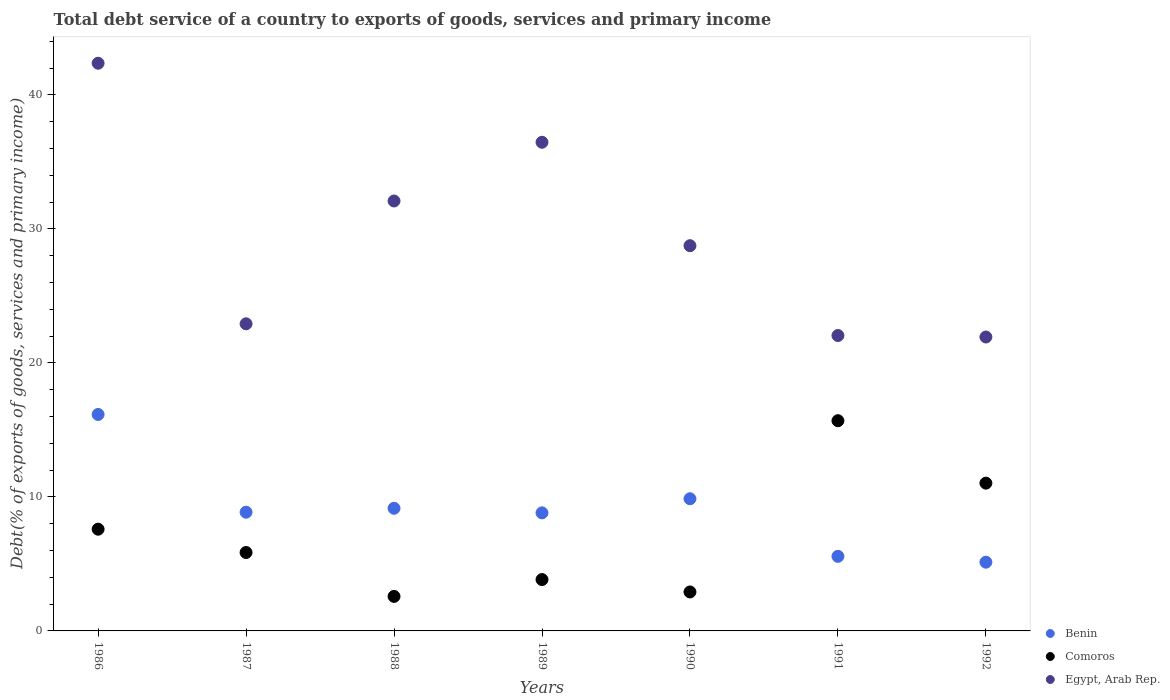Is the number of dotlines equal to the number of legend labels?
Ensure brevity in your answer.  Yes. What is the total debt service in Comoros in 1990?
Make the answer very short. 2.91. Across all years, what is the maximum total debt service in Comoros?
Your answer should be compact. 15.69. Across all years, what is the minimum total debt service in Comoros?
Ensure brevity in your answer.  2.58. In which year was the total debt service in Benin minimum?
Your answer should be compact. 1992. What is the total total debt service in Egypt, Arab Rep. in the graph?
Give a very brief answer. 206.56. What is the difference between the total debt service in Egypt, Arab Rep. in 1986 and that in 1987?
Provide a short and direct response. 19.45. What is the difference between the total debt service in Benin in 1988 and the total debt service in Egypt, Arab Rep. in 1990?
Your response must be concise. -19.6. What is the average total debt service in Comoros per year?
Ensure brevity in your answer.  7.07. In the year 1992, what is the difference between the total debt service in Benin and total debt service in Comoros?
Keep it short and to the point. -5.9. In how many years, is the total debt service in Egypt, Arab Rep. greater than 8 %?
Offer a terse response. 7. What is the ratio of the total debt service in Comoros in 1986 to that in 1992?
Your answer should be compact. 0.69. Is the difference between the total debt service in Benin in 1990 and 1991 greater than the difference between the total debt service in Comoros in 1990 and 1991?
Provide a succinct answer. Yes. What is the difference between the highest and the second highest total debt service in Egypt, Arab Rep.?
Your answer should be compact. 5.9. What is the difference between the highest and the lowest total debt service in Egypt, Arab Rep.?
Your answer should be compact. 20.43. In how many years, is the total debt service in Benin greater than the average total debt service in Benin taken over all years?
Your response must be concise. 3. Is the sum of the total debt service in Egypt, Arab Rep. in 1987 and 1991 greater than the maximum total debt service in Benin across all years?
Ensure brevity in your answer.  Yes. Is it the case that in every year, the sum of the total debt service in Egypt, Arab Rep. and total debt service in Comoros  is greater than the total debt service in Benin?
Your response must be concise. Yes. How many dotlines are there?
Offer a terse response. 3. How many years are there in the graph?
Provide a short and direct response. 7. Does the graph contain any zero values?
Ensure brevity in your answer.  No. Does the graph contain grids?
Provide a succinct answer. No. Where does the legend appear in the graph?
Offer a very short reply. Bottom right. How many legend labels are there?
Offer a terse response. 3. How are the legend labels stacked?
Keep it short and to the point. Vertical. What is the title of the graph?
Provide a short and direct response. Total debt service of a country to exports of goods, services and primary income. Does "Samoa" appear as one of the legend labels in the graph?
Make the answer very short. No. What is the label or title of the Y-axis?
Your answer should be compact. Debt(% of exports of goods, services and primary income). What is the Debt(% of exports of goods, services and primary income) in Benin in 1986?
Your answer should be very brief. 16.15. What is the Debt(% of exports of goods, services and primary income) in Comoros in 1986?
Make the answer very short. 7.59. What is the Debt(% of exports of goods, services and primary income) of Egypt, Arab Rep. in 1986?
Ensure brevity in your answer.  42.36. What is the Debt(% of exports of goods, services and primary income) in Benin in 1987?
Ensure brevity in your answer.  8.86. What is the Debt(% of exports of goods, services and primary income) of Comoros in 1987?
Keep it short and to the point. 5.85. What is the Debt(% of exports of goods, services and primary income) in Egypt, Arab Rep. in 1987?
Provide a succinct answer. 22.92. What is the Debt(% of exports of goods, services and primary income) of Benin in 1988?
Your response must be concise. 9.15. What is the Debt(% of exports of goods, services and primary income) in Comoros in 1988?
Offer a very short reply. 2.58. What is the Debt(% of exports of goods, services and primary income) of Egypt, Arab Rep. in 1988?
Give a very brief answer. 32.08. What is the Debt(% of exports of goods, services and primary income) in Benin in 1989?
Provide a succinct answer. 8.81. What is the Debt(% of exports of goods, services and primary income) of Comoros in 1989?
Provide a short and direct response. 3.83. What is the Debt(% of exports of goods, services and primary income) in Egypt, Arab Rep. in 1989?
Your answer should be very brief. 36.47. What is the Debt(% of exports of goods, services and primary income) in Benin in 1990?
Give a very brief answer. 9.86. What is the Debt(% of exports of goods, services and primary income) in Comoros in 1990?
Offer a very short reply. 2.91. What is the Debt(% of exports of goods, services and primary income) in Egypt, Arab Rep. in 1990?
Ensure brevity in your answer.  28.75. What is the Debt(% of exports of goods, services and primary income) in Benin in 1991?
Provide a short and direct response. 5.57. What is the Debt(% of exports of goods, services and primary income) of Comoros in 1991?
Ensure brevity in your answer.  15.69. What is the Debt(% of exports of goods, services and primary income) of Egypt, Arab Rep. in 1991?
Your answer should be compact. 22.04. What is the Debt(% of exports of goods, services and primary income) in Benin in 1992?
Your response must be concise. 5.13. What is the Debt(% of exports of goods, services and primary income) in Comoros in 1992?
Your answer should be compact. 11.03. What is the Debt(% of exports of goods, services and primary income) of Egypt, Arab Rep. in 1992?
Provide a succinct answer. 21.93. Across all years, what is the maximum Debt(% of exports of goods, services and primary income) of Benin?
Ensure brevity in your answer.  16.15. Across all years, what is the maximum Debt(% of exports of goods, services and primary income) in Comoros?
Provide a short and direct response. 15.69. Across all years, what is the maximum Debt(% of exports of goods, services and primary income) of Egypt, Arab Rep.?
Make the answer very short. 42.36. Across all years, what is the minimum Debt(% of exports of goods, services and primary income) of Benin?
Ensure brevity in your answer.  5.13. Across all years, what is the minimum Debt(% of exports of goods, services and primary income) of Comoros?
Your response must be concise. 2.58. Across all years, what is the minimum Debt(% of exports of goods, services and primary income) of Egypt, Arab Rep.?
Offer a very short reply. 21.93. What is the total Debt(% of exports of goods, services and primary income) of Benin in the graph?
Your answer should be very brief. 63.54. What is the total Debt(% of exports of goods, services and primary income) in Comoros in the graph?
Keep it short and to the point. 49.48. What is the total Debt(% of exports of goods, services and primary income) in Egypt, Arab Rep. in the graph?
Ensure brevity in your answer.  206.56. What is the difference between the Debt(% of exports of goods, services and primary income) of Benin in 1986 and that in 1987?
Provide a succinct answer. 7.29. What is the difference between the Debt(% of exports of goods, services and primary income) of Comoros in 1986 and that in 1987?
Offer a very short reply. 1.74. What is the difference between the Debt(% of exports of goods, services and primary income) of Egypt, Arab Rep. in 1986 and that in 1987?
Your answer should be very brief. 19.45. What is the difference between the Debt(% of exports of goods, services and primary income) in Benin in 1986 and that in 1988?
Provide a short and direct response. 7. What is the difference between the Debt(% of exports of goods, services and primary income) of Comoros in 1986 and that in 1988?
Ensure brevity in your answer.  5.01. What is the difference between the Debt(% of exports of goods, services and primary income) of Egypt, Arab Rep. in 1986 and that in 1988?
Make the answer very short. 10.28. What is the difference between the Debt(% of exports of goods, services and primary income) in Benin in 1986 and that in 1989?
Offer a terse response. 7.34. What is the difference between the Debt(% of exports of goods, services and primary income) in Comoros in 1986 and that in 1989?
Your response must be concise. 3.76. What is the difference between the Debt(% of exports of goods, services and primary income) of Egypt, Arab Rep. in 1986 and that in 1989?
Ensure brevity in your answer.  5.9. What is the difference between the Debt(% of exports of goods, services and primary income) of Benin in 1986 and that in 1990?
Provide a short and direct response. 6.29. What is the difference between the Debt(% of exports of goods, services and primary income) of Comoros in 1986 and that in 1990?
Offer a very short reply. 4.68. What is the difference between the Debt(% of exports of goods, services and primary income) in Egypt, Arab Rep. in 1986 and that in 1990?
Ensure brevity in your answer.  13.62. What is the difference between the Debt(% of exports of goods, services and primary income) in Benin in 1986 and that in 1991?
Keep it short and to the point. 10.59. What is the difference between the Debt(% of exports of goods, services and primary income) of Comoros in 1986 and that in 1991?
Make the answer very short. -8.1. What is the difference between the Debt(% of exports of goods, services and primary income) of Egypt, Arab Rep. in 1986 and that in 1991?
Your response must be concise. 20.32. What is the difference between the Debt(% of exports of goods, services and primary income) in Benin in 1986 and that in 1992?
Offer a terse response. 11.02. What is the difference between the Debt(% of exports of goods, services and primary income) in Comoros in 1986 and that in 1992?
Ensure brevity in your answer.  -3.44. What is the difference between the Debt(% of exports of goods, services and primary income) in Egypt, Arab Rep. in 1986 and that in 1992?
Provide a short and direct response. 20.43. What is the difference between the Debt(% of exports of goods, services and primary income) in Benin in 1987 and that in 1988?
Ensure brevity in your answer.  -0.29. What is the difference between the Debt(% of exports of goods, services and primary income) of Comoros in 1987 and that in 1988?
Keep it short and to the point. 3.28. What is the difference between the Debt(% of exports of goods, services and primary income) in Egypt, Arab Rep. in 1987 and that in 1988?
Your answer should be compact. -9.17. What is the difference between the Debt(% of exports of goods, services and primary income) of Benin in 1987 and that in 1989?
Your response must be concise. 0.05. What is the difference between the Debt(% of exports of goods, services and primary income) in Comoros in 1987 and that in 1989?
Provide a succinct answer. 2.02. What is the difference between the Debt(% of exports of goods, services and primary income) in Egypt, Arab Rep. in 1987 and that in 1989?
Your answer should be very brief. -13.55. What is the difference between the Debt(% of exports of goods, services and primary income) in Benin in 1987 and that in 1990?
Ensure brevity in your answer.  -1. What is the difference between the Debt(% of exports of goods, services and primary income) in Comoros in 1987 and that in 1990?
Make the answer very short. 2.94. What is the difference between the Debt(% of exports of goods, services and primary income) of Egypt, Arab Rep. in 1987 and that in 1990?
Provide a succinct answer. -5.83. What is the difference between the Debt(% of exports of goods, services and primary income) of Benin in 1987 and that in 1991?
Provide a succinct answer. 3.29. What is the difference between the Debt(% of exports of goods, services and primary income) of Comoros in 1987 and that in 1991?
Your response must be concise. -9.84. What is the difference between the Debt(% of exports of goods, services and primary income) of Egypt, Arab Rep. in 1987 and that in 1991?
Your answer should be very brief. 0.87. What is the difference between the Debt(% of exports of goods, services and primary income) of Benin in 1987 and that in 1992?
Give a very brief answer. 3.73. What is the difference between the Debt(% of exports of goods, services and primary income) in Comoros in 1987 and that in 1992?
Make the answer very short. -5.18. What is the difference between the Debt(% of exports of goods, services and primary income) of Egypt, Arab Rep. in 1987 and that in 1992?
Provide a succinct answer. 0.99. What is the difference between the Debt(% of exports of goods, services and primary income) in Benin in 1988 and that in 1989?
Your answer should be compact. 0.34. What is the difference between the Debt(% of exports of goods, services and primary income) of Comoros in 1988 and that in 1989?
Provide a succinct answer. -1.26. What is the difference between the Debt(% of exports of goods, services and primary income) of Egypt, Arab Rep. in 1988 and that in 1989?
Your response must be concise. -4.38. What is the difference between the Debt(% of exports of goods, services and primary income) of Benin in 1988 and that in 1990?
Provide a short and direct response. -0.71. What is the difference between the Debt(% of exports of goods, services and primary income) in Comoros in 1988 and that in 1990?
Ensure brevity in your answer.  -0.33. What is the difference between the Debt(% of exports of goods, services and primary income) in Egypt, Arab Rep. in 1988 and that in 1990?
Offer a terse response. 3.34. What is the difference between the Debt(% of exports of goods, services and primary income) of Benin in 1988 and that in 1991?
Give a very brief answer. 3.59. What is the difference between the Debt(% of exports of goods, services and primary income) of Comoros in 1988 and that in 1991?
Your answer should be very brief. -13.11. What is the difference between the Debt(% of exports of goods, services and primary income) in Egypt, Arab Rep. in 1988 and that in 1991?
Give a very brief answer. 10.04. What is the difference between the Debt(% of exports of goods, services and primary income) of Benin in 1988 and that in 1992?
Offer a very short reply. 4.02. What is the difference between the Debt(% of exports of goods, services and primary income) in Comoros in 1988 and that in 1992?
Provide a short and direct response. -8.45. What is the difference between the Debt(% of exports of goods, services and primary income) in Egypt, Arab Rep. in 1988 and that in 1992?
Give a very brief answer. 10.15. What is the difference between the Debt(% of exports of goods, services and primary income) of Benin in 1989 and that in 1990?
Offer a very short reply. -1.05. What is the difference between the Debt(% of exports of goods, services and primary income) in Comoros in 1989 and that in 1990?
Your answer should be very brief. 0.93. What is the difference between the Debt(% of exports of goods, services and primary income) in Egypt, Arab Rep. in 1989 and that in 1990?
Provide a succinct answer. 7.72. What is the difference between the Debt(% of exports of goods, services and primary income) in Benin in 1989 and that in 1991?
Provide a succinct answer. 3.25. What is the difference between the Debt(% of exports of goods, services and primary income) of Comoros in 1989 and that in 1991?
Provide a short and direct response. -11.85. What is the difference between the Debt(% of exports of goods, services and primary income) of Egypt, Arab Rep. in 1989 and that in 1991?
Give a very brief answer. 14.42. What is the difference between the Debt(% of exports of goods, services and primary income) in Benin in 1989 and that in 1992?
Offer a very short reply. 3.68. What is the difference between the Debt(% of exports of goods, services and primary income) of Comoros in 1989 and that in 1992?
Make the answer very short. -7.2. What is the difference between the Debt(% of exports of goods, services and primary income) of Egypt, Arab Rep. in 1989 and that in 1992?
Provide a succinct answer. 14.53. What is the difference between the Debt(% of exports of goods, services and primary income) in Benin in 1990 and that in 1991?
Your answer should be compact. 4.3. What is the difference between the Debt(% of exports of goods, services and primary income) of Comoros in 1990 and that in 1991?
Your answer should be very brief. -12.78. What is the difference between the Debt(% of exports of goods, services and primary income) of Egypt, Arab Rep. in 1990 and that in 1991?
Offer a very short reply. 6.7. What is the difference between the Debt(% of exports of goods, services and primary income) of Benin in 1990 and that in 1992?
Your answer should be compact. 4.73. What is the difference between the Debt(% of exports of goods, services and primary income) of Comoros in 1990 and that in 1992?
Give a very brief answer. -8.12. What is the difference between the Debt(% of exports of goods, services and primary income) in Egypt, Arab Rep. in 1990 and that in 1992?
Make the answer very short. 6.81. What is the difference between the Debt(% of exports of goods, services and primary income) of Benin in 1991 and that in 1992?
Offer a terse response. 0.44. What is the difference between the Debt(% of exports of goods, services and primary income) of Comoros in 1991 and that in 1992?
Make the answer very short. 4.66. What is the difference between the Debt(% of exports of goods, services and primary income) of Egypt, Arab Rep. in 1991 and that in 1992?
Provide a succinct answer. 0.11. What is the difference between the Debt(% of exports of goods, services and primary income) in Benin in 1986 and the Debt(% of exports of goods, services and primary income) in Comoros in 1987?
Your response must be concise. 10.3. What is the difference between the Debt(% of exports of goods, services and primary income) of Benin in 1986 and the Debt(% of exports of goods, services and primary income) of Egypt, Arab Rep. in 1987?
Keep it short and to the point. -6.76. What is the difference between the Debt(% of exports of goods, services and primary income) of Comoros in 1986 and the Debt(% of exports of goods, services and primary income) of Egypt, Arab Rep. in 1987?
Ensure brevity in your answer.  -15.33. What is the difference between the Debt(% of exports of goods, services and primary income) in Benin in 1986 and the Debt(% of exports of goods, services and primary income) in Comoros in 1988?
Keep it short and to the point. 13.58. What is the difference between the Debt(% of exports of goods, services and primary income) in Benin in 1986 and the Debt(% of exports of goods, services and primary income) in Egypt, Arab Rep. in 1988?
Offer a very short reply. -15.93. What is the difference between the Debt(% of exports of goods, services and primary income) of Comoros in 1986 and the Debt(% of exports of goods, services and primary income) of Egypt, Arab Rep. in 1988?
Your answer should be compact. -24.49. What is the difference between the Debt(% of exports of goods, services and primary income) of Benin in 1986 and the Debt(% of exports of goods, services and primary income) of Comoros in 1989?
Offer a very short reply. 12.32. What is the difference between the Debt(% of exports of goods, services and primary income) of Benin in 1986 and the Debt(% of exports of goods, services and primary income) of Egypt, Arab Rep. in 1989?
Your response must be concise. -20.31. What is the difference between the Debt(% of exports of goods, services and primary income) in Comoros in 1986 and the Debt(% of exports of goods, services and primary income) in Egypt, Arab Rep. in 1989?
Ensure brevity in your answer.  -28.87. What is the difference between the Debt(% of exports of goods, services and primary income) of Benin in 1986 and the Debt(% of exports of goods, services and primary income) of Comoros in 1990?
Keep it short and to the point. 13.25. What is the difference between the Debt(% of exports of goods, services and primary income) of Benin in 1986 and the Debt(% of exports of goods, services and primary income) of Egypt, Arab Rep. in 1990?
Provide a short and direct response. -12.59. What is the difference between the Debt(% of exports of goods, services and primary income) of Comoros in 1986 and the Debt(% of exports of goods, services and primary income) of Egypt, Arab Rep. in 1990?
Your answer should be compact. -21.16. What is the difference between the Debt(% of exports of goods, services and primary income) of Benin in 1986 and the Debt(% of exports of goods, services and primary income) of Comoros in 1991?
Offer a terse response. 0.47. What is the difference between the Debt(% of exports of goods, services and primary income) in Benin in 1986 and the Debt(% of exports of goods, services and primary income) in Egypt, Arab Rep. in 1991?
Your answer should be compact. -5.89. What is the difference between the Debt(% of exports of goods, services and primary income) in Comoros in 1986 and the Debt(% of exports of goods, services and primary income) in Egypt, Arab Rep. in 1991?
Keep it short and to the point. -14.45. What is the difference between the Debt(% of exports of goods, services and primary income) in Benin in 1986 and the Debt(% of exports of goods, services and primary income) in Comoros in 1992?
Offer a very short reply. 5.13. What is the difference between the Debt(% of exports of goods, services and primary income) of Benin in 1986 and the Debt(% of exports of goods, services and primary income) of Egypt, Arab Rep. in 1992?
Your response must be concise. -5.78. What is the difference between the Debt(% of exports of goods, services and primary income) in Comoros in 1986 and the Debt(% of exports of goods, services and primary income) in Egypt, Arab Rep. in 1992?
Provide a short and direct response. -14.34. What is the difference between the Debt(% of exports of goods, services and primary income) of Benin in 1987 and the Debt(% of exports of goods, services and primary income) of Comoros in 1988?
Give a very brief answer. 6.28. What is the difference between the Debt(% of exports of goods, services and primary income) in Benin in 1987 and the Debt(% of exports of goods, services and primary income) in Egypt, Arab Rep. in 1988?
Your answer should be very brief. -23.22. What is the difference between the Debt(% of exports of goods, services and primary income) of Comoros in 1987 and the Debt(% of exports of goods, services and primary income) of Egypt, Arab Rep. in 1988?
Your answer should be compact. -26.23. What is the difference between the Debt(% of exports of goods, services and primary income) in Benin in 1987 and the Debt(% of exports of goods, services and primary income) in Comoros in 1989?
Keep it short and to the point. 5.03. What is the difference between the Debt(% of exports of goods, services and primary income) in Benin in 1987 and the Debt(% of exports of goods, services and primary income) in Egypt, Arab Rep. in 1989?
Provide a succinct answer. -27.61. What is the difference between the Debt(% of exports of goods, services and primary income) in Comoros in 1987 and the Debt(% of exports of goods, services and primary income) in Egypt, Arab Rep. in 1989?
Your answer should be compact. -30.61. What is the difference between the Debt(% of exports of goods, services and primary income) of Benin in 1987 and the Debt(% of exports of goods, services and primary income) of Comoros in 1990?
Your answer should be very brief. 5.95. What is the difference between the Debt(% of exports of goods, services and primary income) of Benin in 1987 and the Debt(% of exports of goods, services and primary income) of Egypt, Arab Rep. in 1990?
Keep it short and to the point. -19.89. What is the difference between the Debt(% of exports of goods, services and primary income) in Comoros in 1987 and the Debt(% of exports of goods, services and primary income) in Egypt, Arab Rep. in 1990?
Ensure brevity in your answer.  -22.9. What is the difference between the Debt(% of exports of goods, services and primary income) in Benin in 1987 and the Debt(% of exports of goods, services and primary income) in Comoros in 1991?
Your answer should be very brief. -6.83. What is the difference between the Debt(% of exports of goods, services and primary income) of Benin in 1987 and the Debt(% of exports of goods, services and primary income) of Egypt, Arab Rep. in 1991?
Provide a succinct answer. -13.18. What is the difference between the Debt(% of exports of goods, services and primary income) of Comoros in 1987 and the Debt(% of exports of goods, services and primary income) of Egypt, Arab Rep. in 1991?
Keep it short and to the point. -16.19. What is the difference between the Debt(% of exports of goods, services and primary income) in Benin in 1987 and the Debt(% of exports of goods, services and primary income) in Comoros in 1992?
Your response must be concise. -2.17. What is the difference between the Debt(% of exports of goods, services and primary income) of Benin in 1987 and the Debt(% of exports of goods, services and primary income) of Egypt, Arab Rep. in 1992?
Make the answer very short. -13.07. What is the difference between the Debt(% of exports of goods, services and primary income) in Comoros in 1987 and the Debt(% of exports of goods, services and primary income) in Egypt, Arab Rep. in 1992?
Keep it short and to the point. -16.08. What is the difference between the Debt(% of exports of goods, services and primary income) of Benin in 1988 and the Debt(% of exports of goods, services and primary income) of Comoros in 1989?
Make the answer very short. 5.32. What is the difference between the Debt(% of exports of goods, services and primary income) of Benin in 1988 and the Debt(% of exports of goods, services and primary income) of Egypt, Arab Rep. in 1989?
Ensure brevity in your answer.  -27.31. What is the difference between the Debt(% of exports of goods, services and primary income) in Comoros in 1988 and the Debt(% of exports of goods, services and primary income) in Egypt, Arab Rep. in 1989?
Keep it short and to the point. -33.89. What is the difference between the Debt(% of exports of goods, services and primary income) of Benin in 1988 and the Debt(% of exports of goods, services and primary income) of Comoros in 1990?
Offer a very short reply. 6.24. What is the difference between the Debt(% of exports of goods, services and primary income) of Benin in 1988 and the Debt(% of exports of goods, services and primary income) of Egypt, Arab Rep. in 1990?
Provide a short and direct response. -19.6. What is the difference between the Debt(% of exports of goods, services and primary income) in Comoros in 1988 and the Debt(% of exports of goods, services and primary income) in Egypt, Arab Rep. in 1990?
Keep it short and to the point. -26.17. What is the difference between the Debt(% of exports of goods, services and primary income) in Benin in 1988 and the Debt(% of exports of goods, services and primary income) in Comoros in 1991?
Your answer should be very brief. -6.54. What is the difference between the Debt(% of exports of goods, services and primary income) of Benin in 1988 and the Debt(% of exports of goods, services and primary income) of Egypt, Arab Rep. in 1991?
Provide a succinct answer. -12.89. What is the difference between the Debt(% of exports of goods, services and primary income) in Comoros in 1988 and the Debt(% of exports of goods, services and primary income) in Egypt, Arab Rep. in 1991?
Your response must be concise. -19.47. What is the difference between the Debt(% of exports of goods, services and primary income) of Benin in 1988 and the Debt(% of exports of goods, services and primary income) of Comoros in 1992?
Your answer should be compact. -1.88. What is the difference between the Debt(% of exports of goods, services and primary income) of Benin in 1988 and the Debt(% of exports of goods, services and primary income) of Egypt, Arab Rep. in 1992?
Your response must be concise. -12.78. What is the difference between the Debt(% of exports of goods, services and primary income) in Comoros in 1988 and the Debt(% of exports of goods, services and primary income) in Egypt, Arab Rep. in 1992?
Offer a terse response. -19.36. What is the difference between the Debt(% of exports of goods, services and primary income) in Benin in 1989 and the Debt(% of exports of goods, services and primary income) in Comoros in 1990?
Your response must be concise. 5.9. What is the difference between the Debt(% of exports of goods, services and primary income) in Benin in 1989 and the Debt(% of exports of goods, services and primary income) in Egypt, Arab Rep. in 1990?
Provide a succinct answer. -19.94. What is the difference between the Debt(% of exports of goods, services and primary income) of Comoros in 1989 and the Debt(% of exports of goods, services and primary income) of Egypt, Arab Rep. in 1990?
Provide a succinct answer. -24.92. What is the difference between the Debt(% of exports of goods, services and primary income) of Benin in 1989 and the Debt(% of exports of goods, services and primary income) of Comoros in 1991?
Provide a succinct answer. -6.88. What is the difference between the Debt(% of exports of goods, services and primary income) in Benin in 1989 and the Debt(% of exports of goods, services and primary income) in Egypt, Arab Rep. in 1991?
Ensure brevity in your answer.  -13.23. What is the difference between the Debt(% of exports of goods, services and primary income) in Comoros in 1989 and the Debt(% of exports of goods, services and primary income) in Egypt, Arab Rep. in 1991?
Make the answer very short. -18.21. What is the difference between the Debt(% of exports of goods, services and primary income) of Benin in 1989 and the Debt(% of exports of goods, services and primary income) of Comoros in 1992?
Provide a short and direct response. -2.22. What is the difference between the Debt(% of exports of goods, services and primary income) in Benin in 1989 and the Debt(% of exports of goods, services and primary income) in Egypt, Arab Rep. in 1992?
Offer a very short reply. -13.12. What is the difference between the Debt(% of exports of goods, services and primary income) of Comoros in 1989 and the Debt(% of exports of goods, services and primary income) of Egypt, Arab Rep. in 1992?
Offer a terse response. -18.1. What is the difference between the Debt(% of exports of goods, services and primary income) in Benin in 1990 and the Debt(% of exports of goods, services and primary income) in Comoros in 1991?
Provide a short and direct response. -5.82. What is the difference between the Debt(% of exports of goods, services and primary income) of Benin in 1990 and the Debt(% of exports of goods, services and primary income) of Egypt, Arab Rep. in 1991?
Offer a very short reply. -12.18. What is the difference between the Debt(% of exports of goods, services and primary income) of Comoros in 1990 and the Debt(% of exports of goods, services and primary income) of Egypt, Arab Rep. in 1991?
Keep it short and to the point. -19.14. What is the difference between the Debt(% of exports of goods, services and primary income) of Benin in 1990 and the Debt(% of exports of goods, services and primary income) of Comoros in 1992?
Keep it short and to the point. -1.16. What is the difference between the Debt(% of exports of goods, services and primary income) in Benin in 1990 and the Debt(% of exports of goods, services and primary income) in Egypt, Arab Rep. in 1992?
Keep it short and to the point. -12.07. What is the difference between the Debt(% of exports of goods, services and primary income) of Comoros in 1990 and the Debt(% of exports of goods, services and primary income) of Egypt, Arab Rep. in 1992?
Give a very brief answer. -19.03. What is the difference between the Debt(% of exports of goods, services and primary income) of Benin in 1991 and the Debt(% of exports of goods, services and primary income) of Comoros in 1992?
Keep it short and to the point. -5.46. What is the difference between the Debt(% of exports of goods, services and primary income) in Benin in 1991 and the Debt(% of exports of goods, services and primary income) in Egypt, Arab Rep. in 1992?
Your response must be concise. -16.37. What is the difference between the Debt(% of exports of goods, services and primary income) of Comoros in 1991 and the Debt(% of exports of goods, services and primary income) of Egypt, Arab Rep. in 1992?
Your answer should be compact. -6.25. What is the average Debt(% of exports of goods, services and primary income) in Benin per year?
Make the answer very short. 9.08. What is the average Debt(% of exports of goods, services and primary income) in Comoros per year?
Offer a terse response. 7.07. What is the average Debt(% of exports of goods, services and primary income) in Egypt, Arab Rep. per year?
Ensure brevity in your answer.  29.51. In the year 1986, what is the difference between the Debt(% of exports of goods, services and primary income) of Benin and Debt(% of exports of goods, services and primary income) of Comoros?
Give a very brief answer. 8.56. In the year 1986, what is the difference between the Debt(% of exports of goods, services and primary income) in Benin and Debt(% of exports of goods, services and primary income) in Egypt, Arab Rep.?
Provide a succinct answer. -26.21. In the year 1986, what is the difference between the Debt(% of exports of goods, services and primary income) in Comoros and Debt(% of exports of goods, services and primary income) in Egypt, Arab Rep.?
Offer a terse response. -34.77. In the year 1987, what is the difference between the Debt(% of exports of goods, services and primary income) of Benin and Debt(% of exports of goods, services and primary income) of Comoros?
Provide a succinct answer. 3.01. In the year 1987, what is the difference between the Debt(% of exports of goods, services and primary income) of Benin and Debt(% of exports of goods, services and primary income) of Egypt, Arab Rep.?
Your response must be concise. -14.06. In the year 1987, what is the difference between the Debt(% of exports of goods, services and primary income) in Comoros and Debt(% of exports of goods, services and primary income) in Egypt, Arab Rep.?
Offer a terse response. -17.07. In the year 1988, what is the difference between the Debt(% of exports of goods, services and primary income) in Benin and Debt(% of exports of goods, services and primary income) in Comoros?
Provide a succinct answer. 6.57. In the year 1988, what is the difference between the Debt(% of exports of goods, services and primary income) of Benin and Debt(% of exports of goods, services and primary income) of Egypt, Arab Rep.?
Give a very brief answer. -22.93. In the year 1988, what is the difference between the Debt(% of exports of goods, services and primary income) of Comoros and Debt(% of exports of goods, services and primary income) of Egypt, Arab Rep.?
Make the answer very short. -29.51. In the year 1989, what is the difference between the Debt(% of exports of goods, services and primary income) in Benin and Debt(% of exports of goods, services and primary income) in Comoros?
Provide a succinct answer. 4.98. In the year 1989, what is the difference between the Debt(% of exports of goods, services and primary income) in Benin and Debt(% of exports of goods, services and primary income) in Egypt, Arab Rep.?
Provide a succinct answer. -27.65. In the year 1989, what is the difference between the Debt(% of exports of goods, services and primary income) of Comoros and Debt(% of exports of goods, services and primary income) of Egypt, Arab Rep.?
Provide a succinct answer. -32.63. In the year 1990, what is the difference between the Debt(% of exports of goods, services and primary income) in Benin and Debt(% of exports of goods, services and primary income) in Comoros?
Your response must be concise. 6.96. In the year 1990, what is the difference between the Debt(% of exports of goods, services and primary income) of Benin and Debt(% of exports of goods, services and primary income) of Egypt, Arab Rep.?
Provide a succinct answer. -18.88. In the year 1990, what is the difference between the Debt(% of exports of goods, services and primary income) in Comoros and Debt(% of exports of goods, services and primary income) in Egypt, Arab Rep.?
Provide a short and direct response. -25.84. In the year 1991, what is the difference between the Debt(% of exports of goods, services and primary income) of Benin and Debt(% of exports of goods, services and primary income) of Comoros?
Your answer should be compact. -10.12. In the year 1991, what is the difference between the Debt(% of exports of goods, services and primary income) in Benin and Debt(% of exports of goods, services and primary income) in Egypt, Arab Rep.?
Provide a short and direct response. -16.48. In the year 1991, what is the difference between the Debt(% of exports of goods, services and primary income) of Comoros and Debt(% of exports of goods, services and primary income) of Egypt, Arab Rep.?
Provide a short and direct response. -6.36. In the year 1992, what is the difference between the Debt(% of exports of goods, services and primary income) of Benin and Debt(% of exports of goods, services and primary income) of Comoros?
Give a very brief answer. -5.9. In the year 1992, what is the difference between the Debt(% of exports of goods, services and primary income) of Benin and Debt(% of exports of goods, services and primary income) of Egypt, Arab Rep.?
Keep it short and to the point. -16.8. In the year 1992, what is the difference between the Debt(% of exports of goods, services and primary income) in Comoros and Debt(% of exports of goods, services and primary income) in Egypt, Arab Rep.?
Ensure brevity in your answer.  -10.91. What is the ratio of the Debt(% of exports of goods, services and primary income) of Benin in 1986 to that in 1987?
Your response must be concise. 1.82. What is the ratio of the Debt(% of exports of goods, services and primary income) of Comoros in 1986 to that in 1987?
Provide a short and direct response. 1.3. What is the ratio of the Debt(% of exports of goods, services and primary income) in Egypt, Arab Rep. in 1986 to that in 1987?
Your response must be concise. 1.85. What is the ratio of the Debt(% of exports of goods, services and primary income) in Benin in 1986 to that in 1988?
Keep it short and to the point. 1.77. What is the ratio of the Debt(% of exports of goods, services and primary income) of Comoros in 1986 to that in 1988?
Your answer should be compact. 2.95. What is the ratio of the Debt(% of exports of goods, services and primary income) of Egypt, Arab Rep. in 1986 to that in 1988?
Your response must be concise. 1.32. What is the ratio of the Debt(% of exports of goods, services and primary income) in Benin in 1986 to that in 1989?
Your response must be concise. 1.83. What is the ratio of the Debt(% of exports of goods, services and primary income) of Comoros in 1986 to that in 1989?
Your response must be concise. 1.98. What is the ratio of the Debt(% of exports of goods, services and primary income) of Egypt, Arab Rep. in 1986 to that in 1989?
Make the answer very short. 1.16. What is the ratio of the Debt(% of exports of goods, services and primary income) in Benin in 1986 to that in 1990?
Provide a short and direct response. 1.64. What is the ratio of the Debt(% of exports of goods, services and primary income) of Comoros in 1986 to that in 1990?
Offer a very short reply. 2.61. What is the ratio of the Debt(% of exports of goods, services and primary income) in Egypt, Arab Rep. in 1986 to that in 1990?
Your answer should be compact. 1.47. What is the ratio of the Debt(% of exports of goods, services and primary income) in Benin in 1986 to that in 1991?
Your answer should be compact. 2.9. What is the ratio of the Debt(% of exports of goods, services and primary income) of Comoros in 1986 to that in 1991?
Offer a terse response. 0.48. What is the ratio of the Debt(% of exports of goods, services and primary income) in Egypt, Arab Rep. in 1986 to that in 1991?
Your answer should be very brief. 1.92. What is the ratio of the Debt(% of exports of goods, services and primary income) of Benin in 1986 to that in 1992?
Your response must be concise. 3.15. What is the ratio of the Debt(% of exports of goods, services and primary income) in Comoros in 1986 to that in 1992?
Give a very brief answer. 0.69. What is the ratio of the Debt(% of exports of goods, services and primary income) of Egypt, Arab Rep. in 1986 to that in 1992?
Your answer should be compact. 1.93. What is the ratio of the Debt(% of exports of goods, services and primary income) of Benin in 1987 to that in 1988?
Keep it short and to the point. 0.97. What is the ratio of the Debt(% of exports of goods, services and primary income) of Comoros in 1987 to that in 1988?
Offer a terse response. 2.27. What is the ratio of the Debt(% of exports of goods, services and primary income) of Egypt, Arab Rep. in 1987 to that in 1988?
Provide a succinct answer. 0.71. What is the ratio of the Debt(% of exports of goods, services and primary income) in Benin in 1987 to that in 1989?
Your response must be concise. 1.01. What is the ratio of the Debt(% of exports of goods, services and primary income) in Comoros in 1987 to that in 1989?
Your response must be concise. 1.53. What is the ratio of the Debt(% of exports of goods, services and primary income) in Egypt, Arab Rep. in 1987 to that in 1989?
Make the answer very short. 0.63. What is the ratio of the Debt(% of exports of goods, services and primary income) of Benin in 1987 to that in 1990?
Ensure brevity in your answer.  0.9. What is the ratio of the Debt(% of exports of goods, services and primary income) in Comoros in 1987 to that in 1990?
Offer a terse response. 2.01. What is the ratio of the Debt(% of exports of goods, services and primary income) of Egypt, Arab Rep. in 1987 to that in 1990?
Give a very brief answer. 0.8. What is the ratio of the Debt(% of exports of goods, services and primary income) of Benin in 1987 to that in 1991?
Offer a very short reply. 1.59. What is the ratio of the Debt(% of exports of goods, services and primary income) in Comoros in 1987 to that in 1991?
Offer a very short reply. 0.37. What is the ratio of the Debt(% of exports of goods, services and primary income) in Egypt, Arab Rep. in 1987 to that in 1991?
Provide a succinct answer. 1.04. What is the ratio of the Debt(% of exports of goods, services and primary income) of Benin in 1987 to that in 1992?
Keep it short and to the point. 1.73. What is the ratio of the Debt(% of exports of goods, services and primary income) of Comoros in 1987 to that in 1992?
Give a very brief answer. 0.53. What is the ratio of the Debt(% of exports of goods, services and primary income) in Egypt, Arab Rep. in 1987 to that in 1992?
Your response must be concise. 1.04. What is the ratio of the Debt(% of exports of goods, services and primary income) of Comoros in 1988 to that in 1989?
Provide a succinct answer. 0.67. What is the ratio of the Debt(% of exports of goods, services and primary income) in Egypt, Arab Rep. in 1988 to that in 1989?
Your answer should be compact. 0.88. What is the ratio of the Debt(% of exports of goods, services and primary income) in Benin in 1988 to that in 1990?
Ensure brevity in your answer.  0.93. What is the ratio of the Debt(% of exports of goods, services and primary income) in Comoros in 1988 to that in 1990?
Make the answer very short. 0.89. What is the ratio of the Debt(% of exports of goods, services and primary income) of Egypt, Arab Rep. in 1988 to that in 1990?
Make the answer very short. 1.12. What is the ratio of the Debt(% of exports of goods, services and primary income) of Benin in 1988 to that in 1991?
Provide a succinct answer. 1.64. What is the ratio of the Debt(% of exports of goods, services and primary income) of Comoros in 1988 to that in 1991?
Keep it short and to the point. 0.16. What is the ratio of the Debt(% of exports of goods, services and primary income) in Egypt, Arab Rep. in 1988 to that in 1991?
Ensure brevity in your answer.  1.46. What is the ratio of the Debt(% of exports of goods, services and primary income) in Benin in 1988 to that in 1992?
Your answer should be compact. 1.78. What is the ratio of the Debt(% of exports of goods, services and primary income) of Comoros in 1988 to that in 1992?
Your response must be concise. 0.23. What is the ratio of the Debt(% of exports of goods, services and primary income) of Egypt, Arab Rep. in 1988 to that in 1992?
Give a very brief answer. 1.46. What is the ratio of the Debt(% of exports of goods, services and primary income) of Benin in 1989 to that in 1990?
Offer a very short reply. 0.89. What is the ratio of the Debt(% of exports of goods, services and primary income) of Comoros in 1989 to that in 1990?
Keep it short and to the point. 1.32. What is the ratio of the Debt(% of exports of goods, services and primary income) in Egypt, Arab Rep. in 1989 to that in 1990?
Provide a short and direct response. 1.27. What is the ratio of the Debt(% of exports of goods, services and primary income) in Benin in 1989 to that in 1991?
Provide a short and direct response. 1.58. What is the ratio of the Debt(% of exports of goods, services and primary income) of Comoros in 1989 to that in 1991?
Provide a succinct answer. 0.24. What is the ratio of the Debt(% of exports of goods, services and primary income) in Egypt, Arab Rep. in 1989 to that in 1991?
Give a very brief answer. 1.65. What is the ratio of the Debt(% of exports of goods, services and primary income) in Benin in 1989 to that in 1992?
Your response must be concise. 1.72. What is the ratio of the Debt(% of exports of goods, services and primary income) in Comoros in 1989 to that in 1992?
Your answer should be compact. 0.35. What is the ratio of the Debt(% of exports of goods, services and primary income) in Egypt, Arab Rep. in 1989 to that in 1992?
Provide a succinct answer. 1.66. What is the ratio of the Debt(% of exports of goods, services and primary income) in Benin in 1990 to that in 1991?
Provide a succinct answer. 1.77. What is the ratio of the Debt(% of exports of goods, services and primary income) of Comoros in 1990 to that in 1991?
Your answer should be very brief. 0.19. What is the ratio of the Debt(% of exports of goods, services and primary income) in Egypt, Arab Rep. in 1990 to that in 1991?
Make the answer very short. 1.3. What is the ratio of the Debt(% of exports of goods, services and primary income) of Benin in 1990 to that in 1992?
Your response must be concise. 1.92. What is the ratio of the Debt(% of exports of goods, services and primary income) of Comoros in 1990 to that in 1992?
Give a very brief answer. 0.26. What is the ratio of the Debt(% of exports of goods, services and primary income) of Egypt, Arab Rep. in 1990 to that in 1992?
Your answer should be very brief. 1.31. What is the ratio of the Debt(% of exports of goods, services and primary income) of Benin in 1991 to that in 1992?
Make the answer very short. 1.08. What is the ratio of the Debt(% of exports of goods, services and primary income) in Comoros in 1991 to that in 1992?
Your answer should be very brief. 1.42. What is the difference between the highest and the second highest Debt(% of exports of goods, services and primary income) in Benin?
Ensure brevity in your answer.  6.29. What is the difference between the highest and the second highest Debt(% of exports of goods, services and primary income) in Comoros?
Offer a very short reply. 4.66. What is the difference between the highest and the second highest Debt(% of exports of goods, services and primary income) in Egypt, Arab Rep.?
Offer a terse response. 5.9. What is the difference between the highest and the lowest Debt(% of exports of goods, services and primary income) of Benin?
Offer a terse response. 11.02. What is the difference between the highest and the lowest Debt(% of exports of goods, services and primary income) in Comoros?
Keep it short and to the point. 13.11. What is the difference between the highest and the lowest Debt(% of exports of goods, services and primary income) of Egypt, Arab Rep.?
Offer a very short reply. 20.43. 